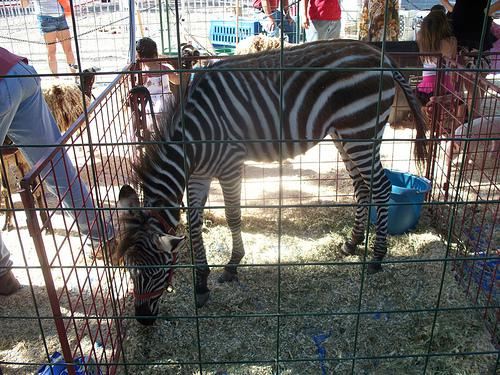Question: what type of animal is shown?
Choices:
A. Zebra.
B. Lion.
C. Tiger.
D. Bear.
Answer with the letter. Answer: A Question: when was the photo taken?
Choices:
A. Evening.
B. Late night.
C. Daytime.
D. Early AM.
Answer with the letter. Answer: C Question: where is the zebra?
Choices:
A. In a cage.
B. At the Zoo.
C. At a compound.
D. Confined.
Answer with the letter. Answer: A Question: who is wearing pink skirt?
Choices:
A. Lady in front row.
B. Girl in background.
C. Girl in the last row.
D. Twins in the front row.
Answer with the letter. Answer: B 